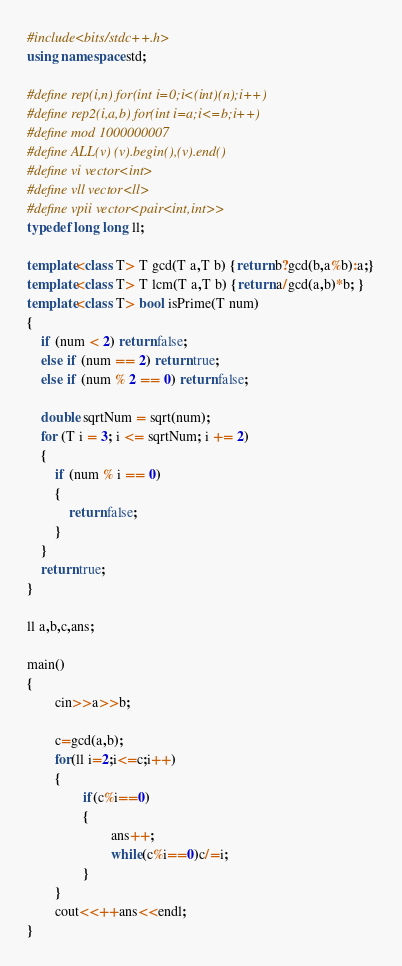<code> <loc_0><loc_0><loc_500><loc_500><_C++_>#include<bits/stdc++.h>
using namespace std;

#define rep(i,n) for(int i=0;i<(int)(n);i++)
#define rep2(i,a,b) for(int i=a;i<=b;i++)
#define mod 1000000007
#define ALL(v) (v).begin(),(v).end()
#define vi vector<int>
#define vll vector<ll>
#define vpii vector<pair<int,int>>
typedef long long ll;

template<class T> T gcd(T a,T b) {return b?gcd(b,a%b):a;}
template<class T> T lcm(T a,T b) {return a/gcd(a,b)*b; }
template<class T> bool isPrime(T num)
{
    if (num < 2) return false;
    else if (num == 2) return true;
    else if (num % 2 == 0) return false;

    double sqrtNum = sqrt(num);
    for (T i = 3; i <= sqrtNum; i += 2)
    {
        if (num % i == 0)
        {
            return false;
        }
    }
    return true;
}

ll a,b,c,ans;

main()
{
        cin>>a>>b;

        c=gcd(a,b);
        for(ll i=2;i<=c;i++)
        {
                if(c%i==0)
                {
                        ans++;
                        while(c%i==0)c/=i;
                }
        }
        cout<<++ans<<endl;
}</code> 